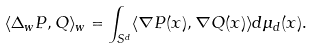<formula> <loc_0><loc_0><loc_500><loc_500>\langle \Delta _ { w } P , Q \rangle _ { w } = \int _ { S ^ { d } } \langle \nabla P ( x ) , \nabla Q ( x ) \rangle d \mu _ { d } ( x ) .</formula> 